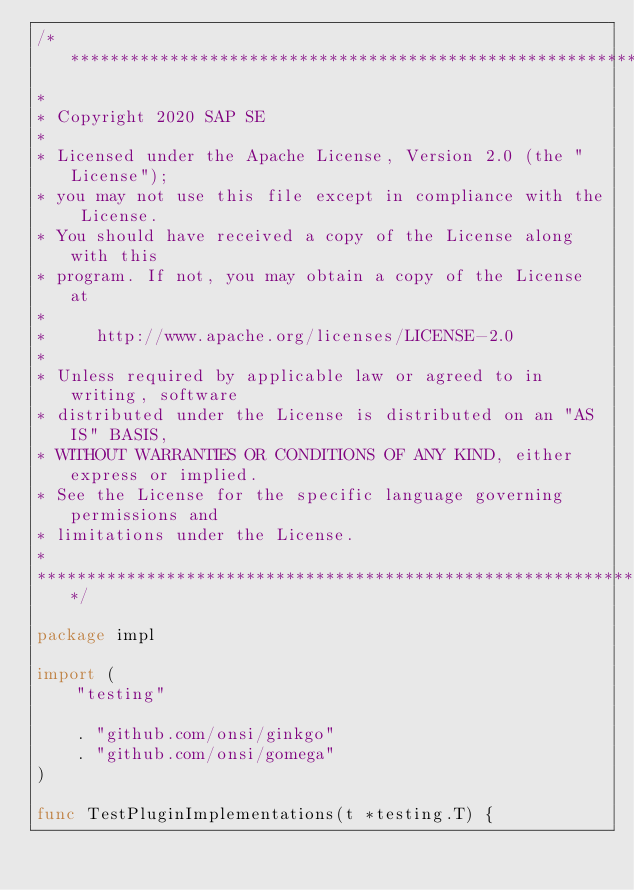Convert code to text. <code><loc_0><loc_0><loc_500><loc_500><_Go_>/*******************************************************************************
*
* Copyright 2020 SAP SE
*
* Licensed under the Apache License, Version 2.0 (the "License");
* you may not use this file except in compliance with the License.
* You should have received a copy of the License along with this
* program. If not, you may obtain a copy of the License at
*
*     http://www.apache.org/licenses/LICENSE-2.0
*
* Unless required by applicable law or agreed to in writing, software
* distributed under the License is distributed on an "AS IS" BASIS,
* WITHOUT WARRANTIES OR CONDITIONS OF ANY KIND, either express or implied.
* See the License for the specific language governing permissions and
* limitations under the License.
*
*******************************************************************************/

package impl

import (
	"testing"

	. "github.com/onsi/ginkgo"
	. "github.com/onsi/gomega"
)

func TestPluginImplementations(t *testing.T) {</code> 